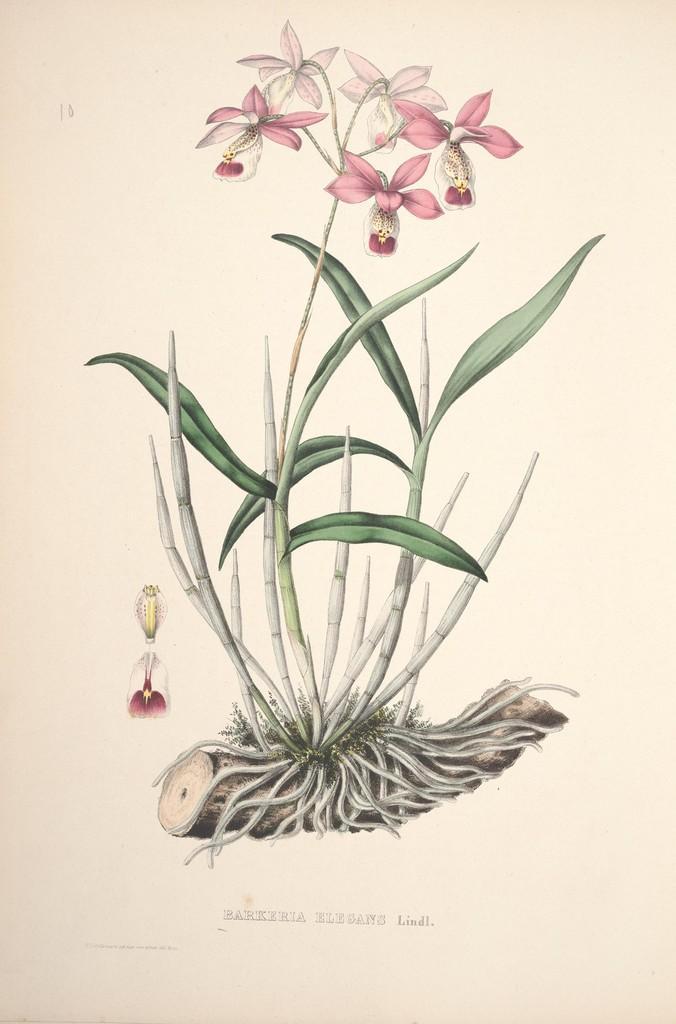In one or two sentences, can you explain what this image depicts? In this image there is a sketch of a plant. There are flowers to the plant. There are roots on the trunk. Below the picture there is text on the image. 